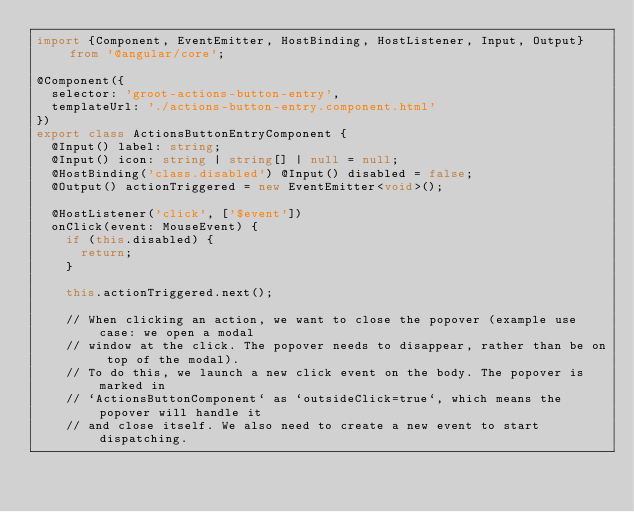Convert code to text. <code><loc_0><loc_0><loc_500><loc_500><_TypeScript_>import {Component, EventEmitter, HostBinding, HostListener, Input, Output} from '@angular/core';

@Component({
  selector: 'groot-actions-button-entry',
  templateUrl: './actions-button-entry.component.html'
})
export class ActionsButtonEntryComponent {
  @Input() label: string;
  @Input() icon: string | string[] | null = null;
  @HostBinding('class.disabled') @Input() disabled = false;
  @Output() actionTriggered = new EventEmitter<void>();

  @HostListener('click', ['$event'])
  onClick(event: MouseEvent) {
    if (this.disabled) {
      return;
    }

    this.actionTriggered.next();

    // When clicking an action, we want to close the popover (example use case: we open a modal
    // window at the click. The popover needs to disappear, rather than be on top of the modal).
    // To do this, we launch a new click event on the body. The popover is marked in
    // `ActionsButtonComponent` as `outsideClick=true`, which means the popover will handle it
    // and close itself. We also need to create a new event to start dispatching.</code> 